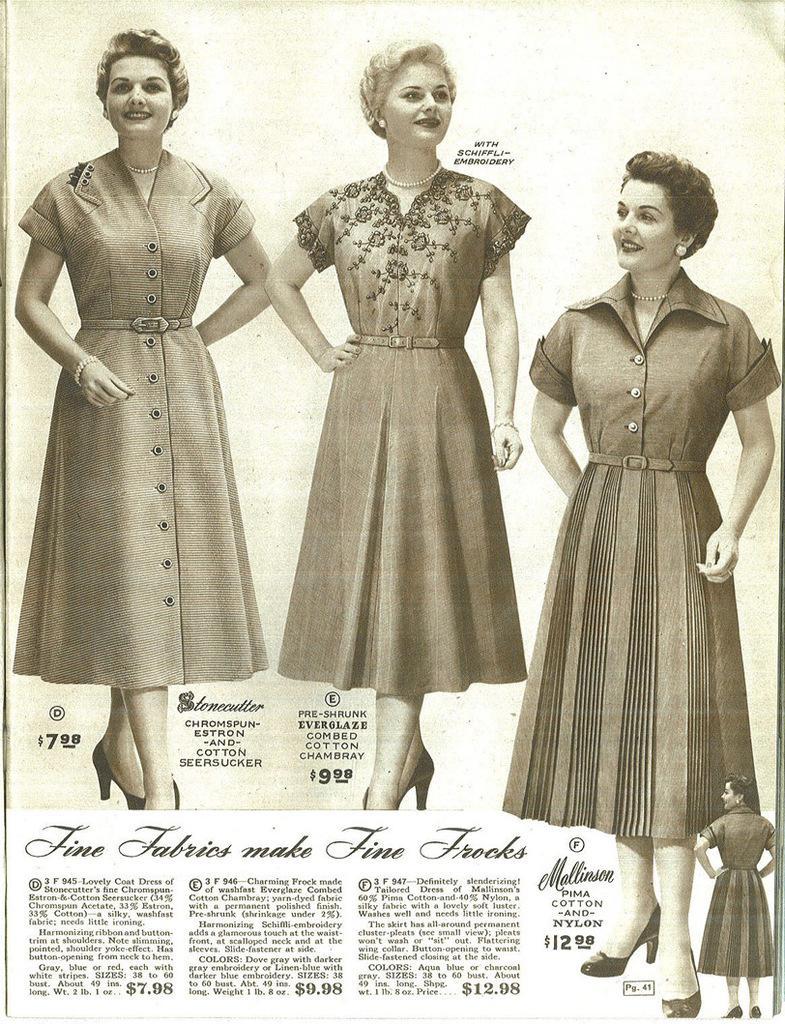Describe this image in one or two sentences. In this image there is a paper and we can see pictures of ladies printed on the paper and there is text. 